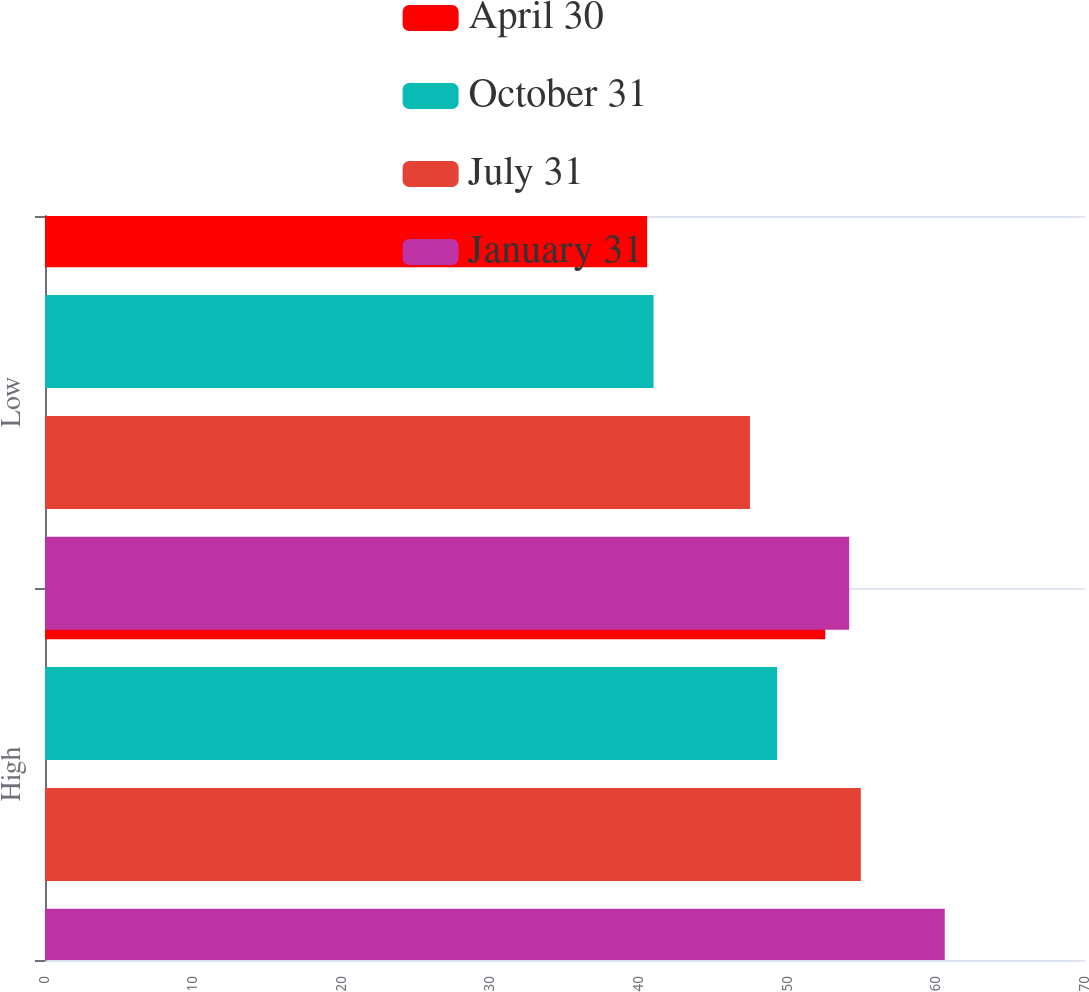<chart> <loc_0><loc_0><loc_500><loc_500><stacked_bar_chart><ecel><fcel>High<fcel>Low<nl><fcel>April 30<fcel>52.52<fcel>40.53<nl><fcel>October 31<fcel>49.28<fcel>40.96<nl><fcel>July 31<fcel>54.91<fcel>47.45<nl><fcel>January 31<fcel>60.56<fcel>54.13<nl></chart> 